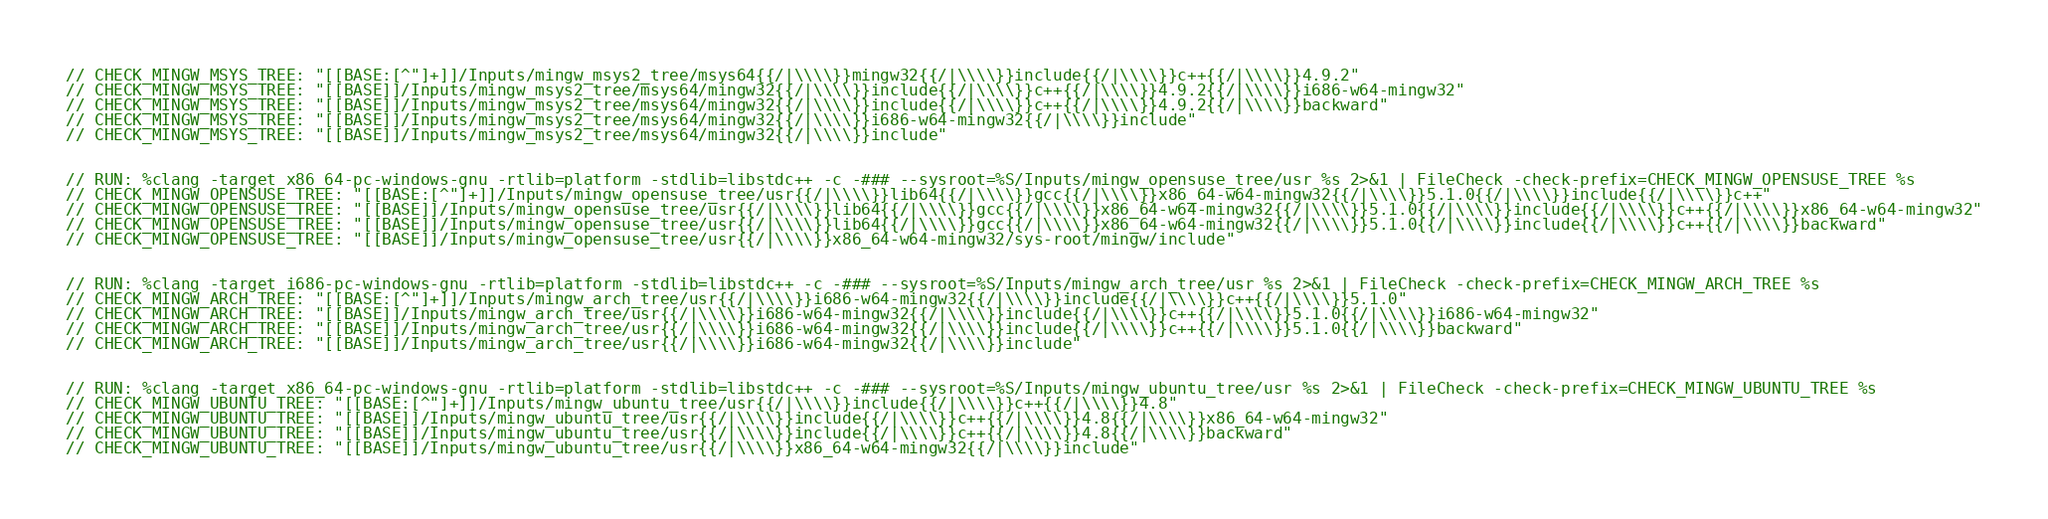<code> <loc_0><loc_0><loc_500><loc_500><_C++_>// CHECK_MINGW_MSYS_TREE: "[[BASE:[^"]+]]/Inputs/mingw_msys2_tree/msys64{{/|\\\\}}mingw32{{/|\\\\}}include{{/|\\\\}}c++{{/|\\\\}}4.9.2"
// CHECK_MINGW_MSYS_TREE: "[[BASE]]/Inputs/mingw_msys2_tree/msys64/mingw32{{/|\\\\}}include{{/|\\\\}}c++{{/|\\\\}}4.9.2{{/|\\\\}}i686-w64-mingw32"
// CHECK_MINGW_MSYS_TREE: "[[BASE]]/Inputs/mingw_msys2_tree/msys64/mingw32{{/|\\\\}}include{{/|\\\\}}c++{{/|\\\\}}4.9.2{{/|\\\\}}backward"
// CHECK_MINGW_MSYS_TREE: "[[BASE]]/Inputs/mingw_msys2_tree/msys64/mingw32{{/|\\\\}}i686-w64-mingw32{{/|\\\\}}include"
// CHECK_MINGW_MSYS_TREE: "[[BASE]]/Inputs/mingw_msys2_tree/msys64/mingw32{{/|\\\\}}include"


// RUN: %clang -target x86_64-pc-windows-gnu -rtlib=platform -stdlib=libstdc++ -c -### --sysroot=%S/Inputs/mingw_opensuse_tree/usr %s 2>&1 | FileCheck -check-prefix=CHECK_MINGW_OPENSUSE_TREE %s
// CHECK_MINGW_OPENSUSE_TREE: "[[BASE:[^"]+]]/Inputs/mingw_opensuse_tree/usr{{/|\\\\}}lib64{{/|\\\\}}gcc{{/|\\\\}}x86_64-w64-mingw32{{/|\\\\}}5.1.0{{/|\\\\}}include{{/|\\\\}}c++"
// CHECK_MINGW_OPENSUSE_TREE: "[[BASE]]/Inputs/mingw_opensuse_tree/usr{{/|\\\\}}lib64{{/|\\\\}}gcc{{/|\\\\}}x86_64-w64-mingw32{{/|\\\\}}5.1.0{{/|\\\\}}include{{/|\\\\}}c++{{/|\\\\}}x86_64-w64-mingw32"
// CHECK_MINGW_OPENSUSE_TREE: "[[BASE]]/Inputs/mingw_opensuse_tree/usr{{/|\\\\}}lib64{{/|\\\\}}gcc{{/|\\\\}}x86_64-w64-mingw32{{/|\\\\}}5.1.0{{/|\\\\}}include{{/|\\\\}}c++{{/|\\\\}}backward"
// CHECK_MINGW_OPENSUSE_TREE: "[[BASE]]/Inputs/mingw_opensuse_tree/usr{{/|\\\\}}x86_64-w64-mingw32/sys-root/mingw/include"


// RUN: %clang -target i686-pc-windows-gnu -rtlib=platform -stdlib=libstdc++ -c -### --sysroot=%S/Inputs/mingw_arch_tree/usr %s 2>&1 | FileCheck -check-prefix=CHECK_MINGW_ARCH_TREE %s
// CHECK_MINGW_ARCH_TREE: "[[BASE:[^"]+]]/Inputs/mingw_arch_tree/usr{{/|\\\\}}i686-w64-mingw32{{/|\\\\}}include{{/|\\\\}}c++{{/|\\\\}}5.1.0"
// CHECK_MINGW_ARCH_TREE: "[[BASE]]/Inputs/mingw_arch_tree/usr{{/|\\\\}}i686-w64-mingw32{{/|\\\\}}include{{/|\\\\}}c++{{/|\\\\}}5.1.0{{/|\\\\}}i686-w64-mingw32"
// CHECK_MINGW_ARCH_TREE: "[[BASE]]/Inputs/mingw_arch_tree/usr{{/|\\\\}}i686-w64-mingw32{{/|\\\\}}include{{/|\\\\}}c++{{/|\\\\}}5.1.0{{/|\\\\}}backward"
// CHECK_MINGW_ARCH_TREE: "[[BASE]]/Inputs/mingw_arch_tree/usr{{/|\\\\}}i686-w64-mingw32{{/|\\\\}}include"


// RUN: %clang -target x86_64-pc-windows-gnu -rtlib=platform -stdlib=libstdc++ -c -### --sysroot=%S/Inputs/mingw_ubuntu_tree/usr %s 2>&1 | FileCheck -check-prefix=CHECK_MINGW_UBUNTU_TREE %s
// CHECK_MINGW_UBUNTU_TREE: "[[BASE:[^"]+]]/Inputs/mingw_ubuntu_tree/usr{{/|\\\\}}include{{/|\\\\}}c++{{/|\\\\}}4.8"
// CHECK_MINGW_UBUNTU_TREE: "[[BASE]]/Inputs/mingw_ubuntu_tree/usr{{/|\\\\}}include{{/|\\\\}}c++{{/|\\\\}}4.8{{/|\\\\}}x86_64-w64-mingw32"
// CHECK_MINGW_UBUNTU_TREE: "[[BASE]]/Inputs/mingw_ubuntu_tree/usr{{/|\\\\}}include{{/|\\\\}}c++{{/|\\\\}}4.8{{/|\\\\}}backward"
// CHECK_MINGW_UBUNTU_TREE: "[[BASE]]/Inputs/mingw_ubuntu_tree/usr{{/|\\\\}}x86_64-w64-mingw32{{/|\\\\}}include"

</code> 